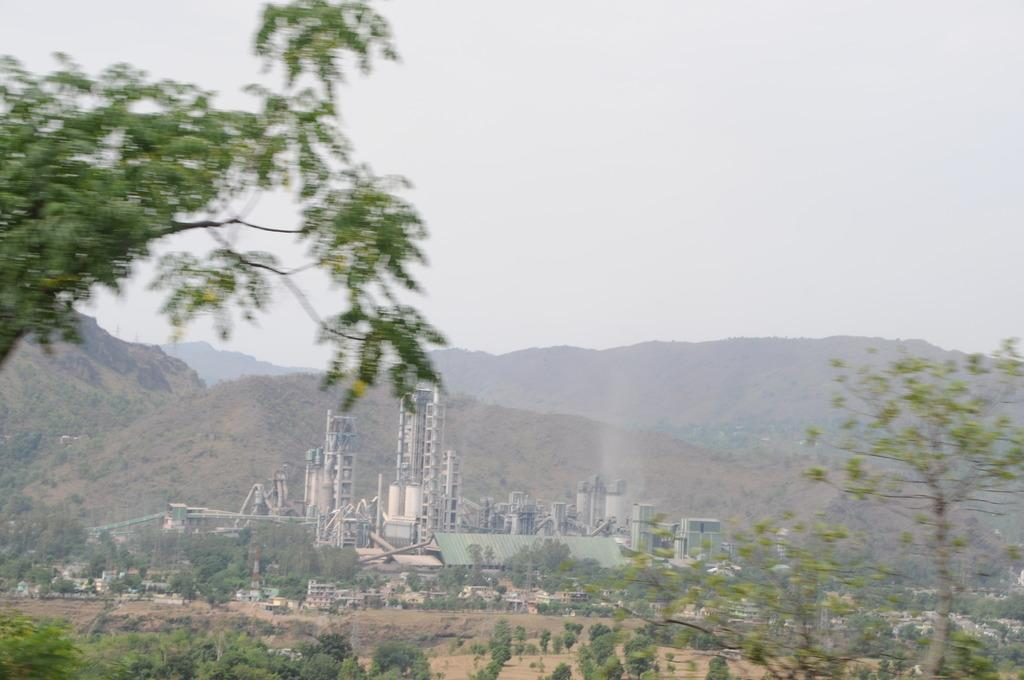What type of location is depicted in the image? The image appears to depict a factory. What natural elements can be seen in the image? There are trees and plants visible in the image. What geographical features are present in the image? There are mountains in the image. What is visible in the sky in the image? The sky is visible in the image. How many ducks are sleeping on the orange in the image? There are no ducks or oranges present in the image. 